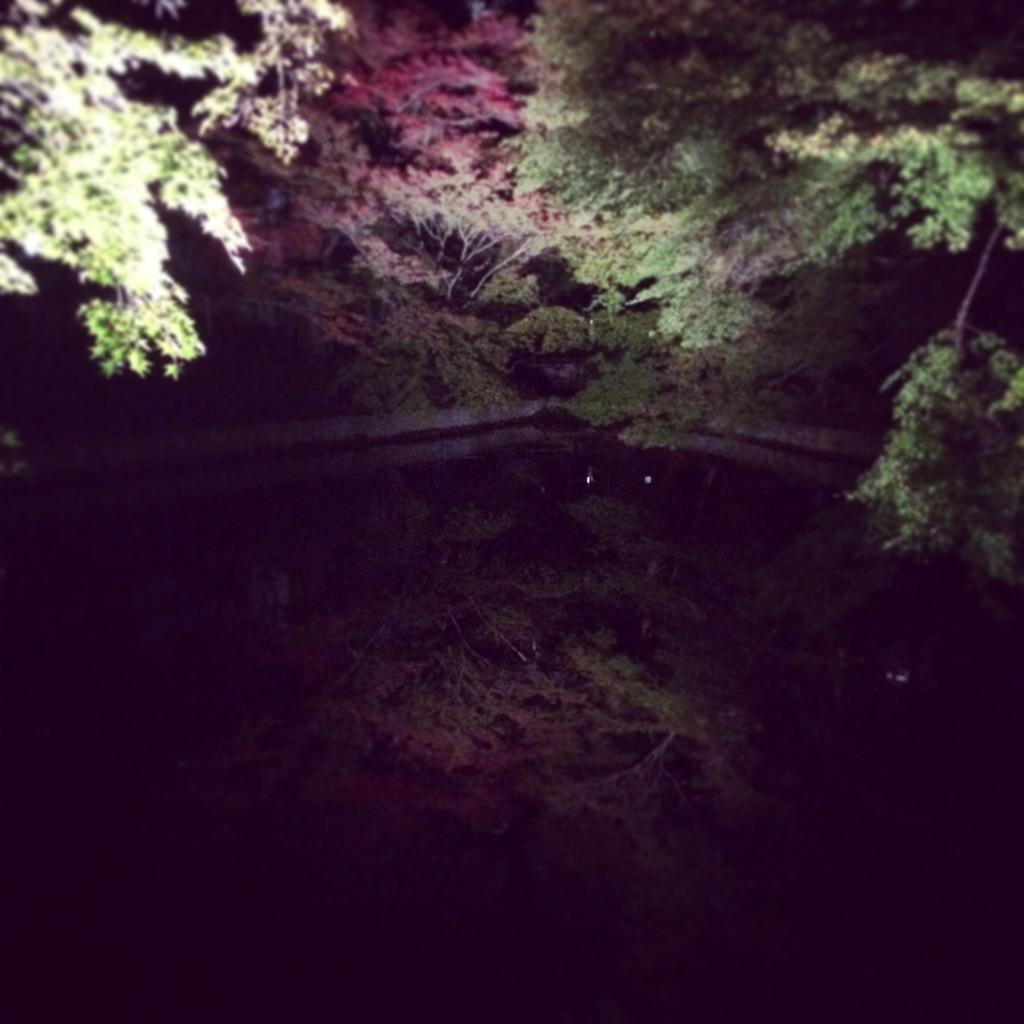What type of vegetation can be seen in the image? There are trees in the image. What natural element is visible in the image besides the trees? There is water visible in the image. What type of action is the muscle performing in the image? There is no muscle or action present in the image; it only features trees and water. 